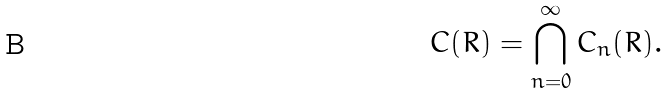<formula> <loc_0><loc_0><loc_500><loc_500>C ( R ) = \bigcap _ { n = 0 } ^ { \infty } C _ { n } ( R ) .</formula> 